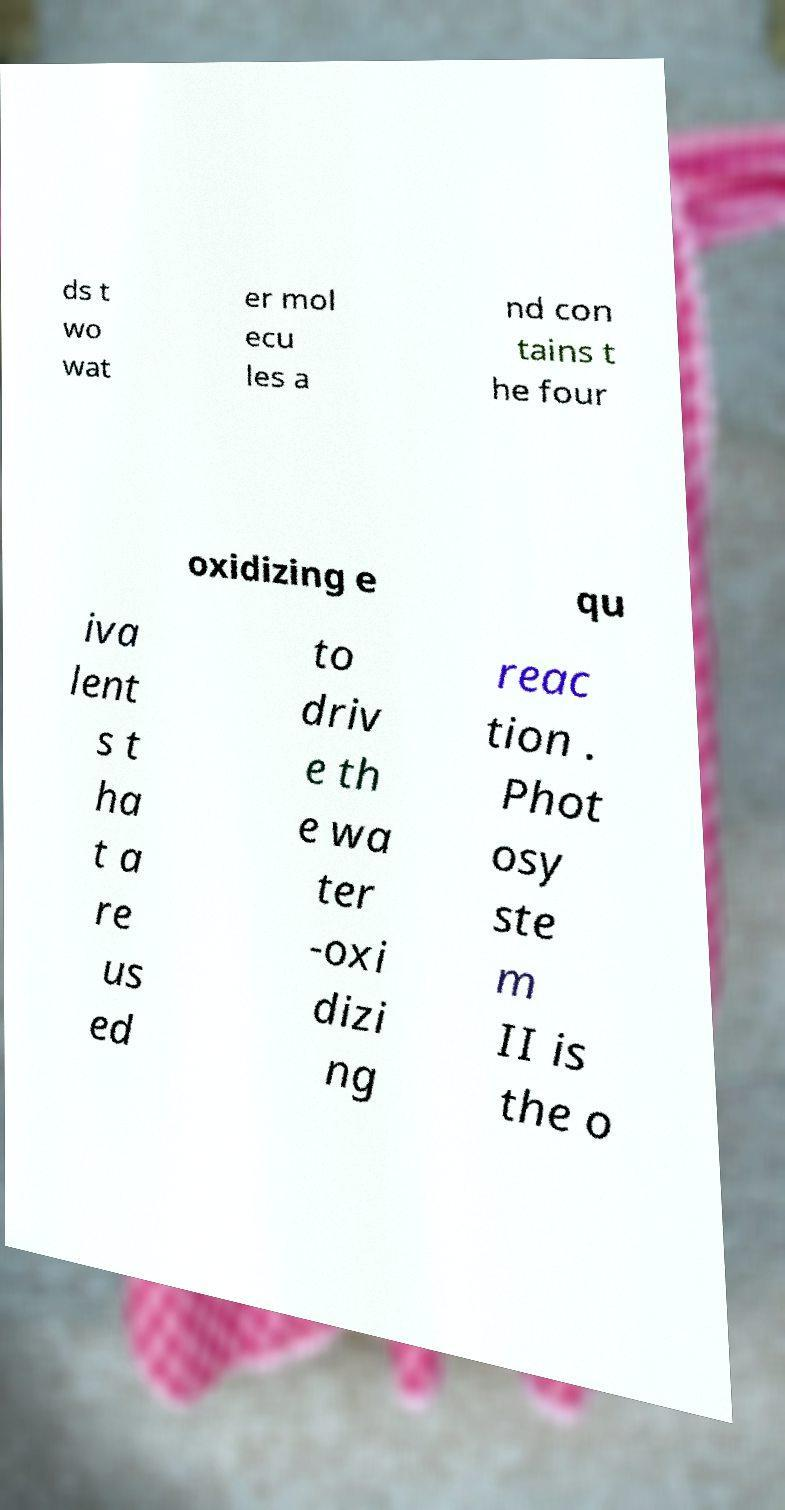There's text embedded in this image that I need extracted. Can you transcribe it verbatim? ds t wo wat er mol ecu les a nd con tains t he four oxidizing e qu iva lent s t ha t a re us ed to driv e th e wa ter -oxi dizi ng reac tion . Phot osy ste m II is the o 